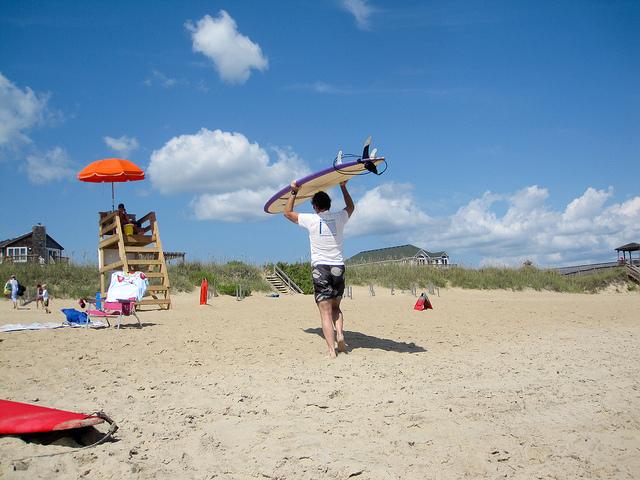What is the occupation of the person sitting under the umbrella?
Be succinct. Lifeguard. Does the surfboard appear heavy?
Answer briefly. Yes. What type of clouds are in the scene?
Write a very short answer. Cumulus. Is there grass on the ground?
Concise answer only. Yes. What objects are in the sky in this picture?
Short answer required. Clouds. Does this scene occur in the desert?
Write a very short answer. No. 